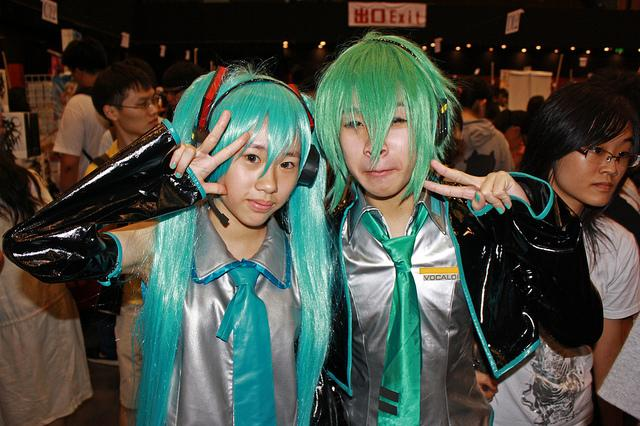What hand gesture are the two doing?

Choices:
A) hang ten
B) thumbs up
C) devil horns
D) peace sign peace sign 